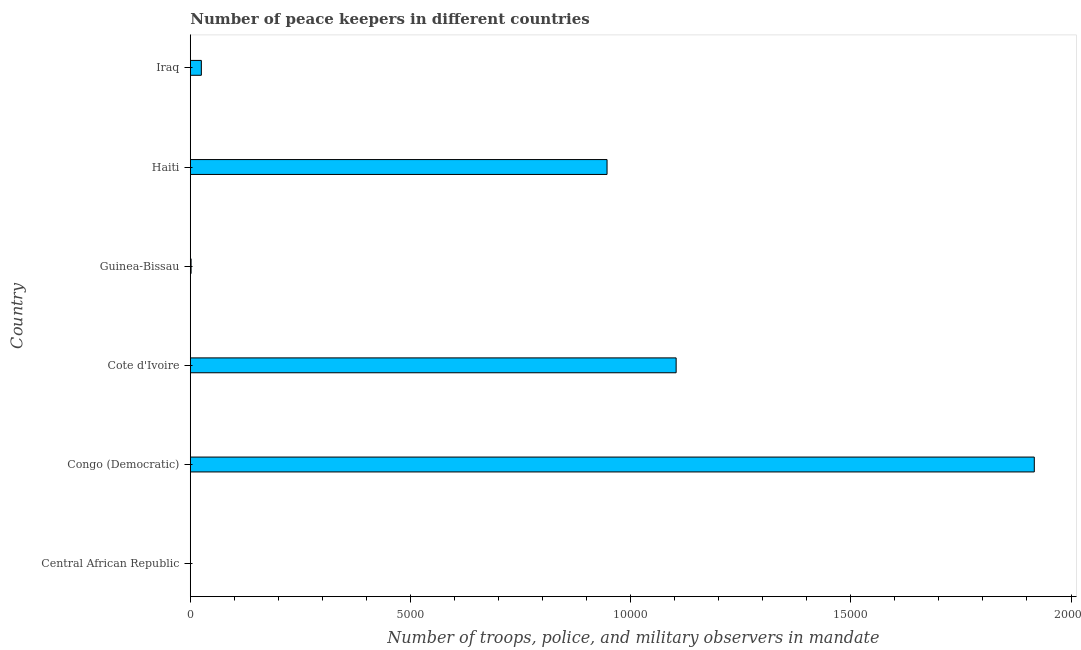Does the graph contain grids?
Provide a short and direct response. No. What is the title of the graph?
Your answer should be compact. Number of peace keepers in different countries. What is the label or title of the X-axis?
Give a very brief answer. Number of troops, police, and military observers in mandate. What is the number of peace keepers in Congo (Democratic)?
Provide a short and direct response. 1.92e+04. Across all countries, what is the maximum number of peace keepers?
Give a very brief answer. 1.92e+04. Across all countries, what is the minimum number of peace keepers?
Offer a terse response. 4. In which country was the number of peace keepers maximum?
Your answer should be very brief. Congo (Democratic). In which country was the number of peace keepers minimum?
Your answer should be very brief. Central African Republic. What is the sum of the number of peace keepers?
Provide a short and direct response. 3.99e+04. What is the difference between the number of peace keepers in Guinea-Bissau and Haiti?
Make the answer very short. -9446. What is the average number of peace keepers per country?
Offer a very short reply. 6656. What is the median number of peace keepers?
Provide a short and direct response. 4857.5. In how many countries, is the number of peace keepers greater than 18000 ?
Your response must be concise. 1. What is the ratio of the number of peace keepers in Central African Republic to that in Iraq?
Your response must be concise. 0.02. What is the difference between the highest and the second highest number of peace keepers?
Give a very brief answer. 8133. Is the sum of the number of peace keepers in Congo (Democratic) and Cote d'Ivoire greater than the maximum number of peace keepers across all countries?
Provide a short and direct response. Yes. What is the difference between the highest and the lowest number of peace keepers?
Your answer should be very brief. 1.92e+04. In how many countries, is the number of peace keepers greater than the average number of peace keepers taken over all countries?
Your response must be concise. 3. How many bars are there?
Ensure brevity in your answer.  6. How many countries are there in the graph?
Provide a succinct answer. 6. Are the values on the major ticks of X-axis written in scientific E-notation?
Offer a very short reply. No. What is the Number of troops, police, and military observers in mandate in Congo (Democratic)?
Offer a terse response. 1.92e+04. What is the Number of troops, police, and military observers in mandate in Cote d'Ivoire?
Offer a very short reply. 1.10e+04. What is the Number of troops, police, and military observers in mandate in Haiti?
Ensure brevity in your answer.  9464. What is the Number of troops, police, and military observers in mandate of Iraq?
Make the answer very short. 251. What is the difference between the Number of troops, police, and military observers in mandate in Central African Republic and Congo (Democratic)?
Give a very brief answer. -1.92e+04. What is the difference between the Number of troops, police, and military observers in mandate in Central African Republic and Cote d'Ivoire?
Provide a succinct answer. -1.10e+04. What is the difference between the Number of troops, police, and military observers in mandate in Central African Republic and Haiti?
Ensure brevity in your answer.  -9460. What is the difference between the Number of troops, police, and military observers in mandate in Central African Republic and Iraq?
Provide a short and direct response. -247. What is the difference between the Number of troops, police, and military observers in mandate in Congo (Democratic) and Cote d'Ivoire?
Your answer should be compact. 8133. What is the difference between the Number of troops, police, and military observers in mandate in Congo (Democratic) and Guinea-Bissau?
Provide a succinct answer. 1.91e+04. What is the difference between the Number of troops, police, and military observers in mandate in Congo (Democratic) and Haiti?
Provide a succinct answer. 9702. What is the difference between the Number of troops, police, and military observers in mandate in Congo (Democratic) and Iraq?
Make the answer very short. 1.89e+04. What is the difference between the Number of troops, police, and military observers in mandate in Cote d'Ivoire and Guinea-Bissau?
Ensure brevity in your answer.  1.10e+04. What is the difference between the Number of troops, police, and military observers in mandate in Cote d'Ivoire and Haiti?
Provide a succinct answer. 1569. What is the difference between the Number of troops, police, and military observers in mandate in Cote d'Ivoire and Iraq?
Your answer should be compact. 1.08e+04. What is the difference between the Number of troops, police, and military observers in mandate in Guinea-Bissau and Haiti?
Provide a short and direct response. -9446. What is the difference between the Number of troops, police, and military observers in mandate in Guinea-Bissau and Iraq?
Give a very brief answer. -233. What is the difference between the Number of troops, police, and military observers in mandate in Haiti and Iraq?
Offer a terse response. 9213. What is the ratio of the Number of troops, police, and military observers in mandate in Central African Republic to that in Guinea-Bissau?
Provide a short and direct response. 0.22. What is the ratio of the Number of troops, police, and military observers in mandate in Central African Republic to that in Iraq?
Keep it short and to the point. 0.02. What is the ratio of the Number of troops, police, and military observers in mandate in Congo (Democratic) to that in Cote d'Ivoire?
Provide a short and direct response. 1.74. What is the ratio of the Number of troops, police, and military observers in mandate in Congo (Democratic) to that in Guinea-Bissau?
Keep it short and to the point. 1064.78. What is the ratio of the Number of troops, police, and military observers in mandate in Congo (Democratic) to that in Haiti?
Your response must be concise. 2.02. What is the ratio of the Number of troops, police, and military observers in mandate in Congo (Democratic) to that in Iraq?
Make the answer very short. 76.36. What is the ratio of the Number of troops, police, and military observers in mandate in Cote d'Ivoire to that in Guinea-Bissau?
Give a very brief answer. 612.94. What is the ratio of the Number of troops, police, and military observers in mandate in Cote d'Ivoire to that in Haiti?
Offer a terse response. 1.17. What is the ratio of the Number of troops, police, and military observers in mandate in Cote d'Ivoire to that in Iraq?
Keep it short and to the point. 43.96. What is the ratio of the Number of troops, police, and military observers in mandate in Guinea-Bissau to that in Haiti?
Provide a succinct answer. 0. What is the ratio of the Number of troops, police, and military observers in mandate in Guinea-Bissau to that in Iraq?
Keep it short and to the point. 0.07. What is the ratio of the Number of troops, police, and military observers in mandate in Haiti to that in Iraq?
Keep it short and to the point. 37.7. 